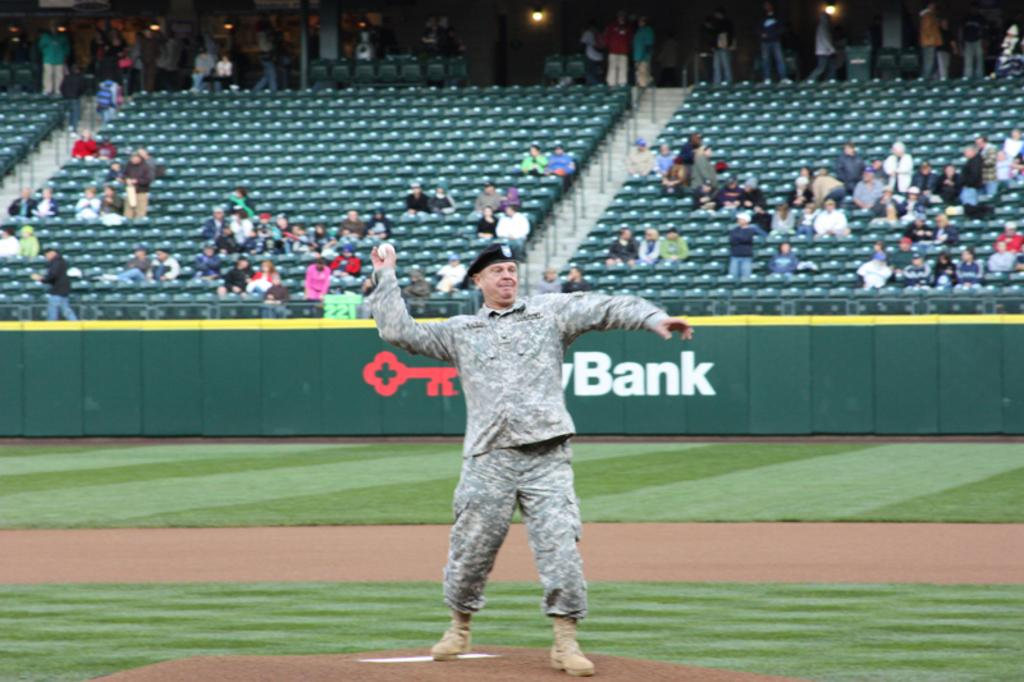<image>
Provide a brief description of the given image. A man in an army uniform is throwing a ball in front of a sign that says the word bank. 